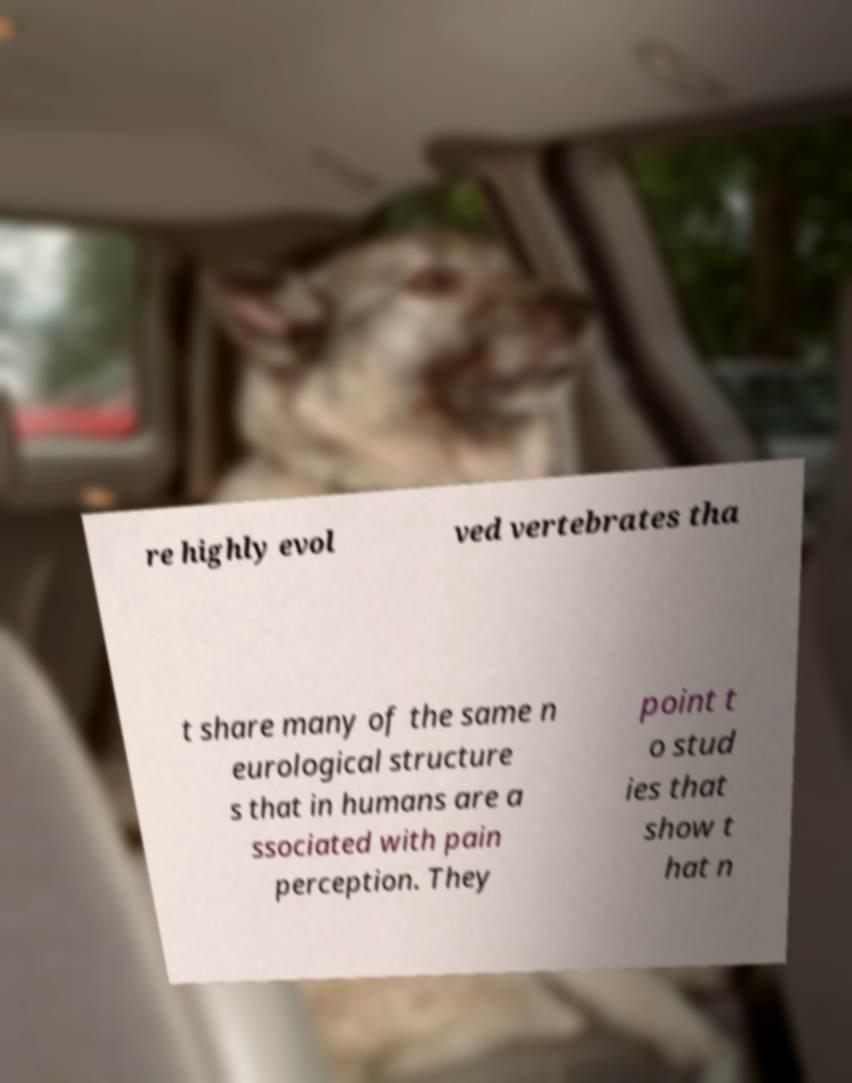Could you assist in decoding the text presented in this image and type it out clearly? re highly evol ved vertebrates tha t share many of the same n eurological structure s that in humans are a ssociated with pain perception. They point t o stud ies that show t hat n 